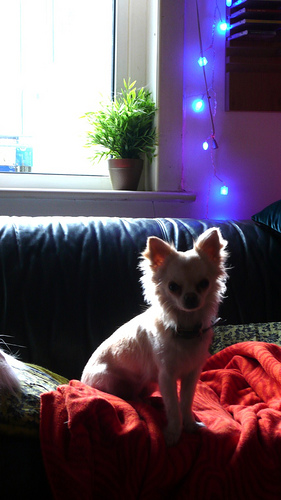<image>
Is the dog on the sofa? Yes. Looking at the image, I can see the dog is positioned on top of the sofa, with the sofa providing support. Where is the christmas light in relation to the window? Is it to the right of the window? Yes. From this viewpoint, the christmas light is positioned to the right side relative to the window. 